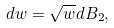Convert formula to latex. <formula><loc_0><loc_0><loc_500><loc_500>d w = \sqrt { w } d B _ { 2 } ,</formula> 